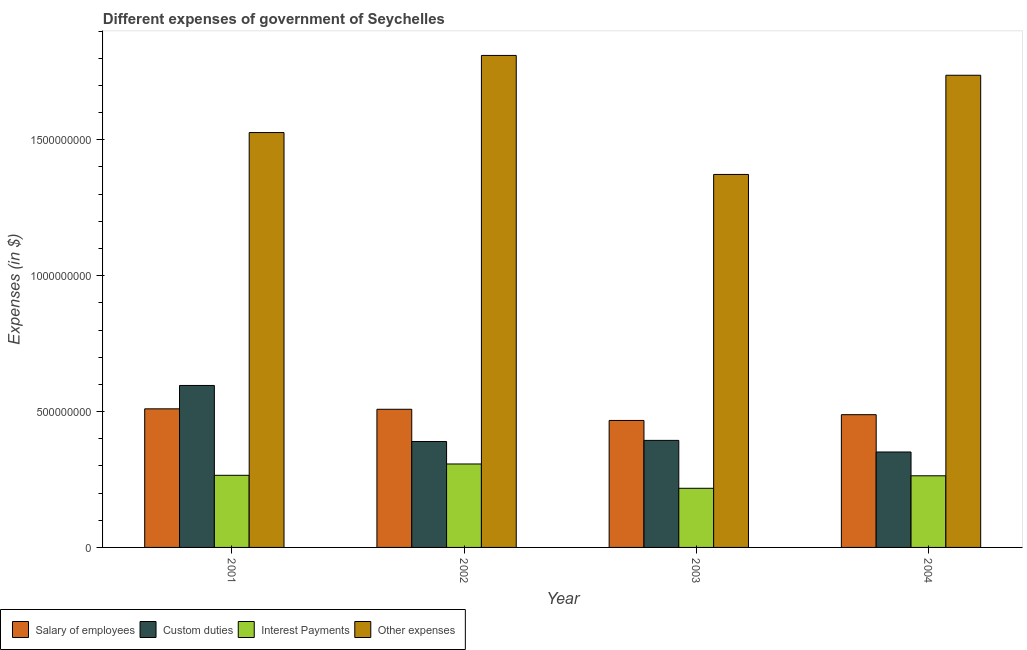How many groups of bars are there?
Your response must be concise. 4. Are the number of bars per tick equal to the number of legend labels?
Give a very brief answer. Yes. How many bars are there on the 2nd tick from the left?
Offer a terse response. 4. What is the amount spent on interest payments in 2004?
Your response must be concise. 2.64e+08. Across all years, what is the maximum amount spent on other expenses?
Your answer should be very brief. 1.81e+09. Across all years, what is the minimum amount spent on salary of employees?
Your answer should be compact. 4.67e+08. What is the total amount spent on interest payments in the graph?
Provide a short and direct response. 1.05e+09. What is the difference between the amount spent on other expenses in 2002 and that in 2003?
Ensure brevity in your answer.  4.38e+08. What is the difference between the amount spent on other expenses in 2003 and the amount spent on salary of employees in 2001?
Provide a succinct answer. -1.54e+08. What is the average amount spent on salary of employees per year?
Your answer should be compact. 4.94e+08. What is the ratio of the amount spent on interest payments in 2002 to that in 2004?
Keep it short and to the point. 1.17. Is the amount spent on salary of employees in 2002 less than that in 2003?
Your answer should be very brief. No. What is the difference between the highest and the second highest amount spent on salary of employees?
Give a very brief answer. 1.60e+06. What is the difference between the highest and the lowest amount spent on interest payments?
Your answer should be compact. 8.95e+07. Is it the case that in every year, the sum of the amount spent on salary of employees and amount spent on interest payments is greater than the sum of amount spent on other expenses and amount spent on custom duties?
Provide a short and direct response. No. What does the 4th bar from the left in 2001 represents?
Keep it short and to the point. Other expenses. What does the 1st bar from the right in 2003 represents?
Ensure brevity in your answer.  Other expenses. What is the difference between two consecutive major ticks on the Y-axis?
Make the answer very short. 5.00e+08. Are the values on the major ticks of Y-axis written in scientific E-notation?
Keep it short and to the point. No. Does the graph contain any zero values?
Offer a very short reply. No. Where does the legend appear in the graph?
Give a very brief answer. Bottom left. How many legend labels are there?
Your answer should be very brief. 4. How are the legend labels stacked?
Keep it short and to the point. Horizontal. What is the title of the graph?
Your answer should be very brief. Different expenses of government of Seychelles. What is the label or title of the X-axis?
Your response must be concise. Year. What is the label or title of the Y-axis?
Provide a short and direct response. Expenses (in $). What is the Expenses (in $) of Salary of employees in 2001?
Provide a succinct answer. 5.10e+08. What is the Expenses (in $) of Custom duties in 2001?
Your response must be concise. 5.96e+08. What is the Expenses (in $) of Interest Payments in 2001?
Your response must be concise. 2.65e+08. What is the Expenses (in $) in Other expenses in 2001?
Your response must be concise. 1.53e+09. What is the Expenses (in $) in Salary of employees in 2002?
Provide a short and direct response. 5.08e+08. What is the Expenses (in $) in Custom duties in 2002?
Make the answer very short. 3.90e+08. What is the Expenses (in $) of Interest Payments in 2002?
Ensure brevity in your answer.  3.07e+08. What is the Expenses (in $) in Other expenses in 2002?
Your response must be concise. 1.81e+09. What is the Expenses (in $) of Salary of employees in 2003?
Your answer should be compact. 4.67e+08. What is the Expenses (in $) of Custom duties in 2003?
Provide a short and direct response. 3.94e+08. What is the Expenses (in $) of Interest Payments in 2003?
Your response must be concise. 2.18e+08. What is the Expenses (in $) of Other expenses in 2003?
Make the answer very short. 1.37e+09. What is the Expenses (in $) in Salary of employees in 2004?
Your answer should be very brief. 4.88e+08. What is the Expenses (in $) in Custom duties in 2004?
Provide a short and direct response. 3.51e+08. What is the Expenses (in $) in Interest Payments in 2004?
Keep it short and to the point. 2.64e+08. What is the Expenses (in $) of Other expenses in 2004?
Make the answer very short. 1.74e+09. Across all years, what is the maximum Expenses (in $) in Salary of employees?
Give a very brief answer. 5.10e+08. Across all years, what is the maximum Expenses (in $) of Custom duties?
Keep it short and to the point. 5.96e+08. Across all years, what is the maximum Expenses (in $) in Interest Payments?
Your answer should be very brief. 3.07e+08. Across all years, what is the maximum Expenses (in $) in Other expenses?
Your answer should be compact. 1.81e+09. Across all years, what is the minimum Expenses (in $) of Salary of employees?
Offer a very short reply. 4.67e+08. Across all years, what is the minimum Expenses (in $) in Custom duties?
Your answer should be very brief. 3.51e+08. Across all years, what is the minimum Expenses (in $) in Interest Payments?
Offer a very short reply. 2.18e+08. Across all years, what is the minimum Expenses (in $) in Other expenses?
Keep it short and to the point. 1.37e+09. What is the total Expenses (in $) in Salary of employees in the graph?
Offer a terse response. 1.97e+09. What is the total Expenses (in $) in Custom duties in the graph?
Provide a short and direct response. 1.73e+09. What is the total Expenses (in $) of Interest Payments in the graph?
Make the answer very short. 1.05e+09. What is the total Expenses (in $) of Other expenses in the graph?
Provide a succinct answer. 6.45e+09. What is the difference between the Expenses (in $) of Salary of employees in 2001 and that in 2002?
Offer a very short reply. 1.60e+06. What is the difference between the Expenses (in $) of Custom duties in 2001 and that in 2002?
Give a very brief answer. 2.06e+08. What is the difference between the Expenses (in $) of Interest Payments in 2001 and that in 2002?
Keep it short and to the point. -4.17e+07. What is the difference between the Expenses (in $) in Other expenses in 2001 and that in 2002?
Your answer should be very brief. -2.84e+08. What is the difference between the Expenses (in $) in Salary of employees in 2001 and that in 2003?
Keep it short and to the point. 4.27e+07. What is the difference between the Expenses (in $) in Custom duties in 2001 and that in 2003?
Your answer should be very brief. 2.02e+08. What is the difference between the Expenses (in $) in Interest Payments in 2001 and that in 2003?
Make the answer very short. 4.78e+07. What is the difference between the Expenses (in $) in Other expenses in 2001 and that in 2003?
Provide a succinct answer. 1.54e+08. What is the difference between the Expenses (in $) in Salary of employees in 2001 and that in 2004?
Offer a very short reply. 2.15e+07. What is the difference between the Expenses (in $) in Custom duties in 2001 and that in 2004?
Your answer should be compact. 2.45e+08. What is the difference between the Expenses (in $) of Interest Payments in 2001 and that in 2004?
Offer a very short reply. 1.80e+06. What is the difference between the Expenses (in $) in Other expenses in 2001 and that in 2004?
Your answer should be very brief. -2.11e+08. What is the difference between the Expenses (in $) in Salary of employees in 2002 and that in 2003?
Your answer should be compact. 4.11e+07. What is the difference between the Expenses (in $) of Custom duties in 2002 and that in 2003?
Provide a short and direct response. -4.10e+06. What is the difference between the Expenses (in $) of Interest Payments in 2002 and that in 2003?
Give a very brief answer. 8.95e+07. What is the difference between the Expenses (in $) in Other expenses in 2002 and that in 2003?
Your answer should be very brief. 4.38e+08. What is the difference between the Expenses (in $) of Salary of employees in 2002 and that in 2004?
Your answer should be very brief. 1.99e+07. What is the difference between the Expenses (in $) of Custom duties in 2002 and that in 2004?
Offer a terse response. 3.86e+07. What is the difference between the Expenses (in $) in Interest Payments in 2002 and that in 2004?
Make the answer very short. 4.35e+07. What is the difference between the Expenses (in $) of Other expenses in 2002 and that in 2004?
Your answer should be compact. 7.30e+07. What is the difference between the Expenses (in $) of Salary of employees in 2003 and that in 2004?
Give a very brief answer. -2.12e+07. What is the difference between the Expenses (in $) in Custom duties in 2003 and that in 2004?
Provide a succinct answer. 4.27e+07. What is the difference between the Expenses (in $) in Interest Payments in 2003 and that in 2004?
Your answer should be very brief. -4.60e+07. What is the difference between the Expenses (in $) of Other expenses in 2003 and that in 2004?
Provide a succinct answer. -3.65e+08. What is the difference between the Expenses (in $) in Salary of employees in 2001 and the Expenses (in $) in Custom duties in 2002?
Provide a succinct answer. 1.20e+08. What is the difference between the Expenses (in $) in Salary of employees in 2001 and the Expenses (in $) in Interest Payments in 2002?
Your response must be concise. 2.03e+08. What is the difference between the Expenses (in $) in Salary of employees in 2001 and the Expenses (in $) in Other expenses in 2002?
Make the answer very short. -1.30e+09. What is the difference between the Expenses (in $) in Custom duties in 2001 and the Expenses (in $) in Interest Payments in 2002?
Your answer should be very brief. 2.89e+08. What is the difference between the Expenses (in $) in Custom duties in 2001 and the Expenses (in $) in Other expenses in 2002?
Ensure brevity in your answer.  -1.21e+09. What is the difference between the Expenses (in $) in Interest Payments in 2001 and the Expenses (in $) in Other expenses in 2002?
Offer a terse response. -1.55e+09. What is the difference between the Expenses (in $) in Salary of employees in 2001 and the Expenses (in $) in Custom duties in 2003?
Your answer should be very brief. 1.16e+08. What is the difference between the Expenses (in $) in Salary of employees in 2001 and the Expenses (in $) in Interest Payments in 2003?
Your answer should be compact. 2.92e+08. What is the difference between the Expenses (in $) in Salary of employees in 2001 and the Expenses (in $) in Other expenses in 2003?
Provide a succinct answer. -8.62e+08. What is the difference between the Expenses (in $) of Custom duties in 2001 and the Expenses (in $) of Interest Payments in 2003?
Your response must be concise. 3.78e+08. What is the difference between the Expenses (in $) in Custom duties in 2001 and the Expenses (in $) in Other expenses in 2003?
Your answer should be very brief. -7.76e+08. What is the difference between the Expenses (in $) of Interest Payments in 2001 and the Expenses (in $) of Other expenses in 2003?
Your answer should be very brief. -1.11e+09. What is the difference between the Expenses (in $) in Salary of employees in 2001 and the Expenses (in $) in Custom duties in 2004?
Your answer should be compact. 1.59e+08. What is the difference between the Expenses (in $) of Salary of employees in 2001 and the Expenses (in $) of Interest Payments in 2004?
Your response must be concise. 2.46e+08. What is the difference between the Expenses (in $) in Salary of employees in 2001 and the Expenses (in $) in Other expenses in 2004?
Offer a terse response. -1.23e+09. What is the difference between the Expenses (in $) in Custom duties in 2001 and the Expenses (in $) in Interest Payments in 2004?
Your response must be concise. 3.32e+08. What is the difference between the Expenses (in $) of Custom duties in 2001 and the Expenses (in $) of Other expenses in 2004?
Your answer should be compact. -1.14e+09. What is the difference between the Expenses (in $) of Interest Payments in 2001 and the Expenses (in $) of Other expenses in 2004?
Your answer should be very brief. -1.47e+09. What is the difference between the Expenses (in $) of Salary of employees in 2002 and the Expenses (in $) of Custom duties in 2003?
Provide a succinct answer. 1.14e+08. What is the difference between the Expenses (in $) of Salary of employees in 2002 and the Expenses (in $) of Interest Payments in 2003?
Your answer should be compact. 2.91e+08. What is the difference between the Expenses (in $) of Salary of employees in 2002 and the Expenses (in $) of Other expenses in 2003?
Keep it short and to the point. -8.64e+08. What is the difference between the Expenses (in $) of Custom duties in 2002 and the Expenses (in $) of Interest Payments in 2003?
Offer a very short reply. 1.72e+08. What is the difference between the Expenses (in $) in Custom duties in 2002 and the Expenses (in $) in Other expenses in 2003?
Make the answer very short. -9.83e+08. What is the difference between the Expenses (in $) in Interest Payments in 2002 and the Expenses (in $) in Other expenses in 2003?
Your response must be concise. -1.07e+09. What is the difference between the Expenses (in $) of Salary of employees in 2002 and the Expenses (in $) of Custom duties in 2004?
Give a very brief answer. 1.57e+08. What is the difference between the Expenses (in $) in Salary of employees in 2002 and the Expenses (in $) in Interest Payments in 2004?
Your answer should be compact. 2.45e+08. What is the difference between the Expenses (in $) in Salary of employees in 2002 and the Expenses (in $) in Other expenses in 2004?
Your response must be concise. -1.23e+09. What is the difference between the Expenses (in $) in Custom duties in 2002 and the Expenses (in $) in Interest Payments in 2004?
Keep it short and to the point. 1.26e+08. What is the difference between the Expenses (in $) in Custom duties in 2002 and the Expenses (in $) in Other expenses in 2004?
Your answer should be compact. -1.35e+09. What is the difference between the Expenses (in $) of Interest Payments in 2002 and the Expenses (in $) of Other expenses in 2004?
Make the answer very short. -1.43e+09. What is the difference between the Expenses (in $) of Salary of employees in 2003 and the Expenses (in $) of Custom duties in 2004?
Provide a short and direct response. 1.16e+08. What is the difference between the Expenses (in $) in Salary of employees in 2003 and the Expenses (in $) in Interest Payments in 2004?
Keep it short and to the point. 2.04e+08. What is the difference between the Expenses (in $) in Salary of employees in 2003 and the Expenses (in $) in Other expenses in 2004?
Give a very brief answer. -1.27e+09. What is the difference between the Expenses (in $) in Custom duties in 2003 and the Expenses (in $) in Interest Payments in 2004?
Keep it short and to the point. 1.30e+08. What is the difference between the Expenses (in $) of Custom duties in 2003 and the Expenses (in $) of Other expenses in 2004?
Your answer should be very brief. -1.34e+09. What is the difference between the Expenses (in $) of Interest Payments in 2003 and the Expenses (in $) of Other expenses in 2004?
Provide a succinct answer. -1.52e+09. What is the average Expenses (in $) in Salary of employees per year?
Provide a short and direct response. 4.94e+08. What is the average Expenses (in $) of Custom duties per year?
Offer a terse response. 4.33e+08. What is the average Expenses (in $) of Interest Payments per year?
Give a very brief answer. 2.63e+08. What is the average Expenses (in $) of Other expenses per year?
Provide a short and direct response. 1.61e+09. In the year 2001, what is the difference between the Expenses (in $) in Salary of employees and Expenses (in $) in Custom duties?
Give a very brief answer. -8.60e+07. In the year 2001, what is the difference between the Expenses (in $) of Salary of employees and Expenses (in $) of Interest Payments?
Provide a succinct answer. 2.45e+08. In the year 2001, what is the difference between the Expenses (in $) in Salary of employees and Expenses (in $) in Other expenses?
Give a very brief answer. -1.02e+09. In the year 2001, what is the difference between the Expenses (in $) in Custom duties and Expenses (in $) in Interest Payments?
Your answer should be compact. 3.31e+08. In the year 2001, what is the difference between the Expenses (in $) of Custom duties and Expenses (in $) of Other expenses?
Give a very brief answer. -9.31e+08. In the year 2001, what is the difference between the Expenses (in $) of Interest Payments and Expenses (in $) of Other expenses?
Your answer should be very brief. -1.26e+09. In the year 2002, what is the difference between the Expenses (in $) in Salary of employees and Expenses (in $) in Custom duties?
Provide a short and direct response. 1.19e+08. In the year 2002, what is the difference between the Expenses (in $) in Salary of employees and Expenses (in $) in Interest Payments?
Your answer should be compact. 2.01e+08. In the year 2002, what is the difference between the Expenses (in $) in Salary of employees and Expenses (in $) in Other expenses?
Your response must be concise. -1.30e+09. In the year 2002, what is the difference between the Expenses (in $) in Custom duties and Expenses (in $) in Interest Payments?
Make the answer very short. 8.27e+07. In the year 2002, what is the difference between the Expenses (in $) in Custom duties and Expenses (in $) in Other expenses?
Offer a terse response. -1.42e+09. In the year 2002, what is the difference between the Expenses (in $) of Interest Payments and Expenses (in $) of Other expenses?
Your answer should be very brief. -1.50e+09. In the year 2003, what is the difference between the Expenses (in $) of Salary of employees and Expenses (in $) of Custom duties?
Give a very brief answer. 7.34e+07. In the year 2003, what is the difference between the Expenses (in $) in Salary of employees and Expenses (in $) in Interest Payments?
Provide a succinct answer. 2.50e+08. In the year 2003, what is the difference between the Expenses (in $) of Salary of employees and Expenses (in $) of Other expenses?
Keep it short and to the point. -9.05e+08. In the year 2003, what is the difference between the Expenses (in $) of Custom duties and Expenses (in $) of Interest Payments?
Your answer should be very brief. 1.76e+08. In the year 2003, what is the difference between the Expenses (in $) in Custom duties and Expenses (in $) in Other expenses?
Offer a terse response. -9.79e+08. In the year 2003, what is the difference between the Expenses (in $) in Interest Payments and Expenses (in $) in Other expenses?
Provide a succinct answer. -1.15e+09. In the year 2004, what is the difference between the Expenses (in $) of Salary of employees and Expenses (in $) of Custom duties?
Provide a succinct answer. 1.37e+08. In the year 2004, what is the difference between the Expenses (in $) of Salary of employees and Expenses (in $) of Interest Payments?
Keep it short and to the point. 2.25e+08. In the year 2004, what is the difference between the Expenses (in $) of Salary of employees and Expenses (in $) of Other expenses?
Ensure brevity in your answer.  -1.25e+09. In the year 2004, what is the difference between the Expenses (in $) in Custom duties and Expenses (in $) in Interest Payments?
Provide a succinct answer. 8.76e+07. In the year 2004, what is the difference between the Expenses (in $) of Custom duties and Expenses (in $) of Other expenses?
Your answer should be compact. -1.39e+09. In the year 2004, what is the difference between the Expenses (in $) in Interest Payments and Expenses (in $) in Other expenses?
Your response must be concise. -1.47e+09. What is the ratio of the Expenses (in $) in Salary of employees in 2001 to that in 2002?
Provide a succinct answer. 1. What is the ratio of the Expenses (in $) in Custom duties in 2001 to that in 2002?
Your answer should be compact. 1.53. What is the ratio of the Expenses (in $) of Interest Payments in 2001 to that in 2002?
Provide a short and direct response. 0.86. What is the ratio of the Expenses (in $) in Other expenses in 2001 to that in 2002?
Your response must be concise. 0.84. What is the ratio of the Expenses (in $) in Salary of employees in 2001 to that in 2003?
Offer a terse response. 1.09. What is the ratio of the Expenses (in $) of Custom duties in 2001 to that in 2003?
Make the answer very short. 1.51. What is the ratio of the Expenses (in $) of Interest Payments in 2001 to that in 2003?
Your response must be concise. 1.22. What is the ratio of the Expenses (in $) of Other expenses in 2001 to that in 2003?
Your response must be concise. 1.11. What is the ratio of the Expenses (in $) of Salary of employees in 2001 to that in 2004?
Your answer should be very brief. 1.04. What is the ratio of the Expenses (in $) in Custom duties in 2001 to that in 2004?
Offer a very short reply. 1.7. What is the ratio of the Expenses (in $) of Interest Payments in 2001 to that in 2004?
Provide a succinct answer. 1.01. What is the ratio of the Expenses (in $) in Other expenses in 2001 to that in 2004?
Your answer should be very brief. 0.88. What is the ratio of the Expenses (in $) in Salary of employees in 2002 to that in 2003?
Make the answer very short. 1.09. What is the ratio of the Expenses (in $) of Interest Payments in 2002 to that in 2003?
Offer a terse response. 1.41. What is the ratio of the Expenses (in $) in Other expenses in 2002 to that in 2003?
Your answer should be compact. 1.32. What is the ratio of the Expenses (in $) in Salary of employees in 2002 to that in 2004?
Your response must be concise. 1.04. What is the ratio of the Expenses (in $) of Custom duties in 2002 to that in 2004?
Provide a succinct answer. 1.11. What is the ratio of the Expenses (in $) in Interest Payments in 2002 to that in 2004?
Keep it short and to the point. 1.17. What is the ratio of the Expenses (in $) in Other expenses in 2002 to that in 2004?
Offer a terse response. 1.04. What is the ratio of the Expenses (in $) in Salary of employees in 2003 to that in 2004?
Give a very brief answer. 0.96. What is the ratio of the Expenses (in $) of Custom duties in 2003 to that in 2004?
Your answer should be very brief. 1.12. What is the ratio of the Expenses (in $) in Interest Payments in 2003 to that in 2004?
Make the answer very short. 0.83. What is the ratio of the Expenses (in $) in Other expenses in 2003 to that in 2004?
Keep it short and to the point. 0.79. What is the difference between the highest and the second highest Expenses (in $) of Salary of employees?
Keep it short and to the point. 1.60e+06. What is the difference between the highest and the second highest Expenses (in $) of Custom duties?
Offer a very short reply. 2.02e+08. What is the difference between the highest and the second highest Expenses (in $) in Interest Payments?
Your answer should be very brief. 4.17e+07. What is the difference between the highest and the second highest Expenses (in $) of Other expenses?
Give a very brief answer. 7.30e+07. What is the difference between the highest and the lowest Expenses (in $) in Salary of employees?
Give a very brief answer. 4.27e+07. What is the difference between the highest and the lowest Expenses (in $) in Custom duties?
Give a very brief answer. 2.45e+08. What is the difference between the highest and the lowest Expenses (in $) of Interest Payments?
Offer a very short reply. 8.95e+07. What is the difference between the highest and the lowest Expenses (in $) in Other expenses?
Keep it short and to the point. 4.38e+08. 